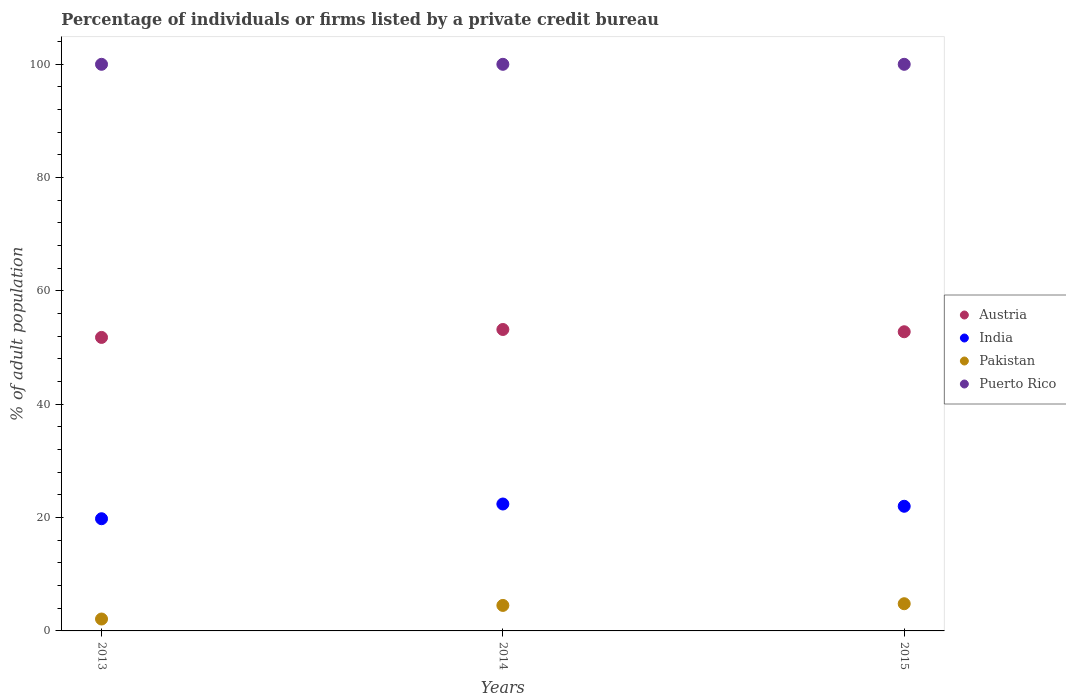How many different coloured dotlines are there?
Your answer should be compact. 4. Is the number of dotlines equal to the number of legend labels?
Keep it short and to the point. Yes. Across all years, what is the maximum percentage of population listed by a private credit bureau in Austria?
Make the answer very short. 53.2. Across all years, what is the minimum percentage of population listed by a private credit bureau in India?
Ensure brevity in your answer.  19.8. What is the total percentage of population listed by a private credit bureau in Puerto Rico in the graph?
Make the answer very short. 300. What is the difference between the percentage of population listed by a private credit bureau in Austria in 2015 and the percentage of population listed by a private credit bureau in India in 2014?
Your response must be concise. 30.4. In the year 2013, what is the difference between the percentage of population listed by a private credit bureau in Pakistan and percentage of population listed by a private credit bureau in Austria?
Provide a succinct answer. -49.7. What is the ratio of the percentage of population listed by a private credit bureau in Austria in 2013 to that in 2015?
Provide a succinct answer. 0.98. Is the percentage of population listed by a private credit bureau in Puerto Rico in 2013 less than that in 2015?
Make the answer very short. No. Is the difference between the percentage of population listed by a private credit bureau in Pakistan in 2013 and 2015 greater than the difference between the percentage of population listed by a private credit bureau in Austria in 2013 and 2015?
Your response must be concise. No. What is the difference between the highest and the second highest percentage of population listed by a private credit bureau in Puerto Rico?
Provide a short and direct response. 0. What is the difference between the highest and the lowest percentage of population listed by a private credit bureau in Pakistan?
Your answer should be compact. 2.7. Is it the case that in every year, the sum of the percentage of population listed by a private credit bureau in Puerto Rico and percentage of population listed by a private credit bureau in India  is greater than the sum of percentage of population listed by a private credit bureau in Austria and percentage of population listed by a private credit bureau in Pakistan?
Your answer should be compact. Yes. Is it the case that in every year, the sum of the percentage of population listed by a private credit bureau in India and percentage of population listed by a private credit bureau in Austria  is greater than the percentage of population listed by a private credit bureau in Puerto Rico?
Give a very brief answer. No. Is the percentage of population listed by a private credit bureau in Puerto Rico strictly less than the percentage of population listed by a private credit bureau in India over the years?
Provide a succinct answer. No. Does the graph contain any zero values?
Keep it short and to the point. No. Does the graph contain grids?
Your response must be concise. No. Where does the legend appear in the graph?
Your answer should be very brief. Center right. How many legend labels are there?
Offer a terse response. 4. What is the title of the graph?
Make the answer very short. Percentage of individuals or firms listed by a private credit bureau. Does "Andorra" appear as one of the legend labels in the graph?
Provide a short and direct response. No. What is the label or title of the Y-axis?
Make the answer very short. % of adult population. What is the % of adult population in Austria in 2013?
Offer a very short reply. 51.8. What is the % of adult population of India in 2013?
Provide a short and direct response. 19.8. What is the % of adult population of Pakistan in 2013?
Your answer should be compact. 2.1. What is the % of adult population in Puerto Rico in 2013?
Ensure brevity in your answer.  100. What is the % of adult population in Austria in 2014?
Ensure brevity in your answer.  53.2. What is the % of adult population in India in 2014?
Provide a short and direct response. 22.4. What is the % of adult population in Pakistan in 2014?
Offer a very short reply. 4.5. What is the % of adult population of Austria in 2015?
Offer a very short reply. 52.8. What is the % of adult population in India in 2015?
Give a very brief answer. 22. What is the % of adult population in Pakistan in 2015?
Offer a very short reply. 4.8. Across all years, what is the maximum % of adult population in Austria?
Make the answer very short. 53.2. Across all years, what is the maximum % of adult population of India?
Provide a succinct answer. 22.4. Across all years, what is the minimum % of adult population of Austria?
Keep it short and to the point. 51.8. Across all years, what is the minimum % of adult population of India?
Provide a short and direct response. 19.8. Across all years, what is the minimum % of adult population of Pakistan?
Keep it short and to the point. 2.1. Across all years, what is the minimum % of adult population of Puerto Rico?
Ensure brevity in your answer.  100. What is the total % of adult population in Austria in the graph?
Make the answer very short. 157.8. What is the total % of adult population of India in the graph?
Your response must be concise. 64.2. What is the total % of adult population of Puerto Rico in the graph?
Make the answer very short. 300. What is the difference between the % of adult population in Austria in 2013 and that in 2015?
Your response must be concise. -1. What is the difference between the % of adult population in Puerto Rico in 2013 and that in 2015?
Offer a very short reply. 0. What is the difference between the % of adult population of India in 2014 and that in 2015?
Give a very brief answer. 0.4. What is the difference between the % of adult population in Pakistan in 2014 and that in 2015?
Give a very brief answer. -0.3. What is the difference between the % of adult population in Austria in 2013 and the % of adult population in India in 2014?
Provide a succinct answer. 29.4. What is the difference between the % of adult population of Austria in 2013 and the % of adult population of Pakistan in 2014?
Your answer should be very brief. 47.3. What is the difference between the % of adult population of Austria in 2013 and the % of adult population of Puerto Rico in 2014?
Provide a short and direct response. -48.2. What is the difference between the % of adult population of India in 2013 and the % of adult population of Puerto Rico in 2014?
Ensure brevity in your answer.  -80.2. What is the difference between the % of adult population of Pakistan in 2013 and the % of adult population of Puerto Rico in 2014?
Give a very brief answer. -97.9. What is the difference between the % of adult population in Austria in 2013 and the % of adult population in India in 2015?
Make the answer very short. 29.8. What is the difference between the % of adult population in Austria in 2013 and the % of adult population in Pakistan in 2015?
Ensure brevity in your answer.  47. What is the difference between the % of adult population of Austria in 2013 and the % of adult population of Puerto Rico in 2015?
Your answer should be very brief. -48.2. What is the difference between the % of adult population in India in 2013 and the % of adult population in Puerto Rico in 2015?
Give a very brief answer. -80.2. What is the difference between the % of adult population in Pakistan in 2013 and the % of adult population in Puerto Rico in 2015?
Your response must be concise. -97.9. What is the difference between the % of adult population of Austria in 2014 and the % of adult population of India in 2015?
Make the answer very short. 31.2. What is the difference between the % of adult population of Austria in 2014 and the % of adult population of Pakistan in 2015?
Give a very brief answer. 48.4. What is the difference between the % of adult population of Austria in 2014 and the % of adult population of Puerto Rico in 2015?
Provide a succinct answer. -46.8. What is the difference between the % of adult population in India in 2014 and the % of adult population in Pakistan in 2015?
Make the answer very short. 17.6. What is the difference between the % of adult population of India in 2014 and the % of adult population of Puerto Rico in 2015?
Provide a succinct answer. -77.6. What is the difference between the % of adult population of Pakistan in 2014 and the % of adult population of Puerto Rico in 2015?
Ensure brevity in your answer.  -95.5. What is the average % of adult population in Austria per year?
Your answer should be very brief. 52.6. What is the average % of adult population in India per year?
Keep it short and to the point. 21.4. What is the average % of adult population of Puerto Rico per year?
Your response must be concise. 100. In the year 2013, what is the difference between the % of adult population in Austria and % of adult population in Pakistan?
Offer a very short reply. 49.7. In the year 2013, what is the difference between the % of adult population of Austria and % of adult population of Puerto Rico?
Provide a short and direct response. -48.2. In the year 2013, what is the difference between the % of adult population in India and % of adult population in Puerto Rico?
Your response must be concise. -80.2. In the year 2013, what is the difference between the % of adult population in Pakistan and % of adult population in Puerto Rico?
Keep it short and to the point. -97.9. In the year 2014, what is the difference between the % of adult population in Austria and % of adult population in India?
Ensure brevity in your answer.  30.8. In the year 2014, what is the difference between the % of adult population in Austria and % of adult population in Pakistan?
Your response must be concise. 48.7. In the year 2014, what is the difference between the % of adult population of Austria and % of adult population of Puerto Rico?
Offer a very short reply. -46.8. In the year 2014, what is the difference between the % of adult population of India and % of adult population of Puerto Rico?
Offer a very short reply. -77.6. In the year 2014, what is the difference between the % of adult population of Pakistan and % of adult population of Puerto Rico?
Ensure brevity in your answer.  -95.5. In the year 2015, what is the difference between the % of adult population of Austria and % of adult population of India?
Ensure brevity in your answer.  30.8. In the year 2015, what is the difference between the % of adult population of Austria and % of adult population of Pakistan?
Keep it short and to the point. 48. In the year 2015, what is the difference between the % of adult population in Austria and % of adult population in Puerto Rico?
Provide a short and direct response. -47.2. In the year 2015, what is the difference between the % of adult population of India and % of adult population of Puerto Rico?
Ensure brevity in your answer.  -78. In the year 2015, what is the difference between the % of adult population in Pakistan and % of adult population in Puerto Rico?
Ensure brevity in your answer.  -95.2. What is the ratio of the % of adult population in Austria in 2013 to that in 2014?
Your response must be concise. 0.97. What is the ratio of the % of adult population of India in 2013 to that in 2014?
Offer a very short reply. 0.88. What is the ratio of the % of adult population of Pakistan in 2013 to that in 2014?
Keep it short and to the point. 0.47. What is the ratio of the % of adult population in Austria in 2013 to that in 2015?
Offer a terse response. 0.98. What is the ratio of the % of adult population in India in 2013 to that in 2015?
Provide a succinct answer. 0.9. What is the ratio of the % of adult population in Pakistan in 2013 to that in 2015?
Ensure brevity in your answer.  0.44. What is the ratio of the % of adult population in Austria in 2014 to that in 2015?
Your answer should be compact. 1.01. What is the ratio of the % of adult population of India in 2014 to that in 2015?
Your response must be concise. 1.02. What is the ratio of the % of adult population in Puerto Rico in 2014 to that in 2015?
Give a very brief answer. 1. What is the difference between the highest and the second highest % of adult population of Austria?
Keep it short and to the point. 0.4. What is the difference between the highest and the second highest % of adult population in India?
Provide a short and direct response. 0.4. What is the difference between the highest and the second highest % of adult population of Pakistan?
Keep it short and to the point. 0.3. What is the difference between the highest and the lowest % of adult population in Austria?
Provide a succinct answer. 1.4. What is the difference between the highest and the lowest % of adult population of Puerto Rico?
Your response must be concise. 0. 